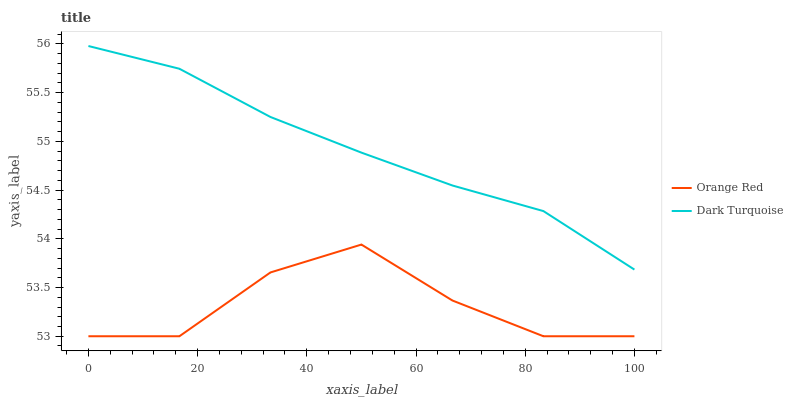Does Orange Red have the minimum area under the curve?
Answer yes or no. Yes. Does Dark Turquoise have the maximum area under the curve?
Answer yes or no. Yes. Does Orange Red have the maximum area under the curve?
Answer yes or no. No. Is Dark Turquoise the smoothest?
Answer yes or no. Yes. Is Orange Red the roughest?
Answer yes or no. Yes. Is Orange Red the smoothest?
Answer yes or no. No. Does Orange Red have the lowest value?
Answer yes or no. Yes. Does Dark Turquoise have the highest value?
Answer yes or no. Yes. Does Orange Red have the highest value?
Answer yes or no. No. Is Orange Red less than Dark Turquoise?
Answer yes or no. Yes. Is Dark Turquoise greater than Orange Red?
Answer yes or no. Yes. Does Orange Red intersect Dark Turquoise?
Answer yes or no. No. 